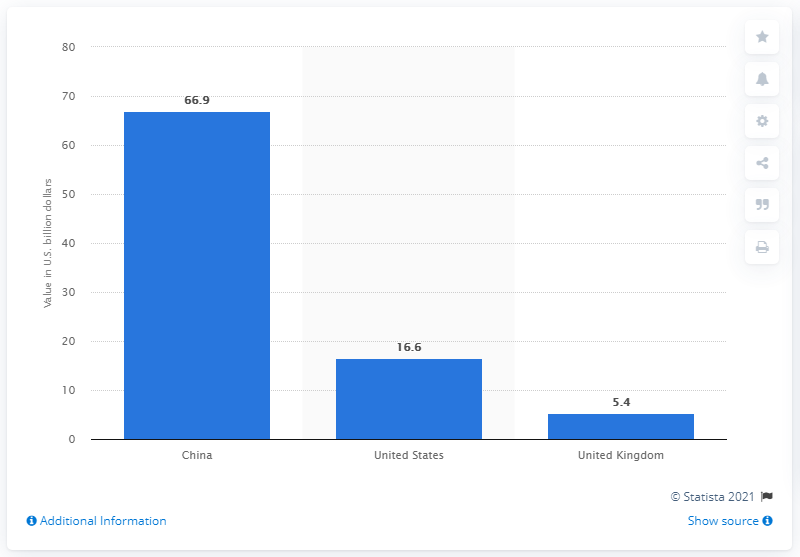Outline some significant characteristics in this image. In 2015, the value of P2P loans in the United States was approximately 16.6 billion dollars. 